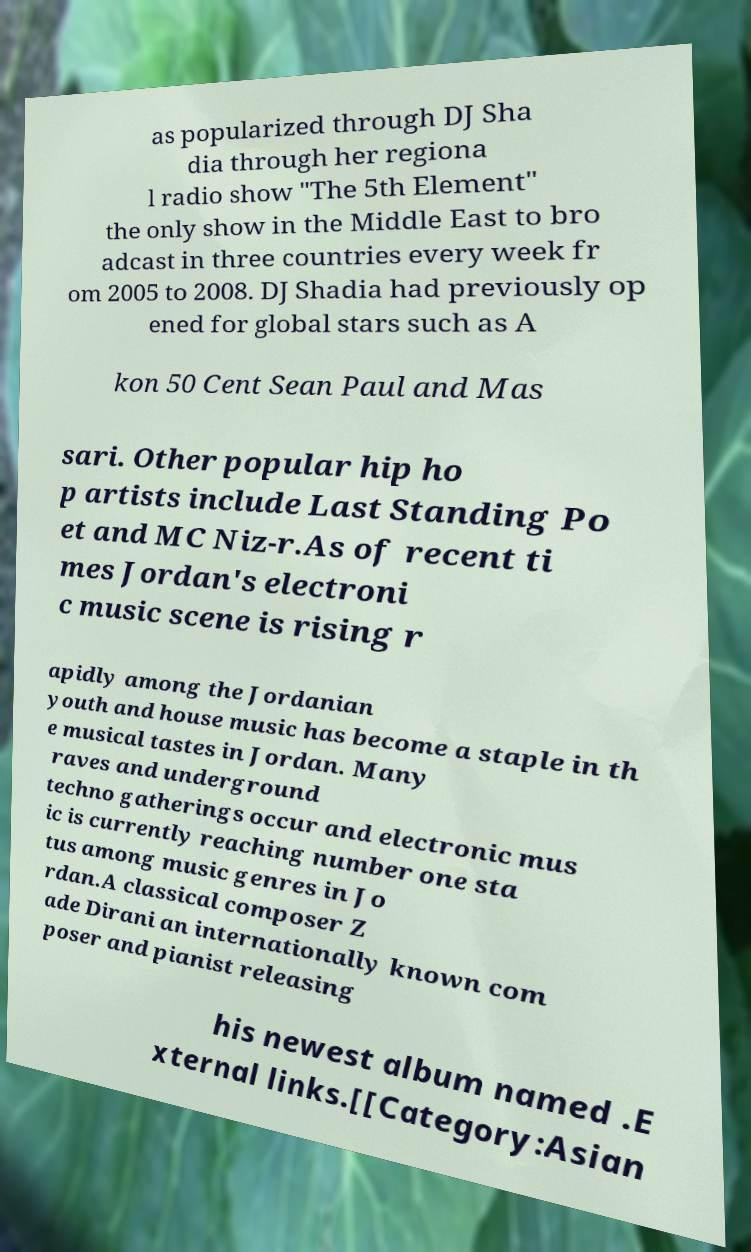Please identify and transcribe the text found in this image. as popularized through DJ Sha dia through her regiona l radio show "The 5th Element" the only show in the Middle East to bro adcast in three countries every week fr om 2005 to 2008. DJ Shadia had previously op ened for global stars such as A kon 50 Cent Sean Paul and Mas sari. Other popular hip ho p artists include Last Standing Po et and MC Niz-r.As of recent ti mes Jordan's electroni c music scene is rising r apidly among the Jordanian youth and house music has become a staple in th e musical tastes in Jordan. Many raves and underground techno gatherings occur and electronic mus ic is currently reaching number one sta tus among music genres in Jo rdan.A classical composer Z ade Dirani an internationally known com poser and pianist releasing his newest album named .E xternal links.[[Category:Asian 